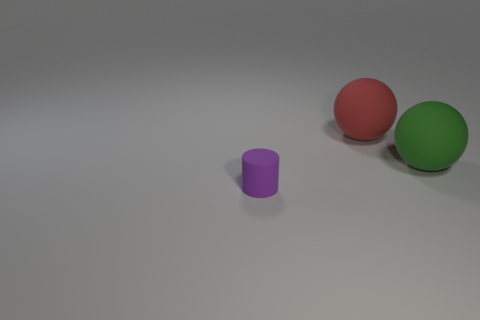Are there any other things that are the same size as the cylinder?
Give a very brief answer. No. What is the size of the purple cylinder that is the same material as the big green thing?
Your answer should be very brief. Small. The ball to the left of the big thing that is to the right of the big red matte object is what color?
Your answer should be compact. Red. How many other things are the same material as the tiny object?
Provide a short and direct response. 2. How many metal things are either small purple objects or spheres?
Offer a very short reply. 0. Are there any green things made of the same material as the big red object?
Give a very brief answer. Yes. The object behind the matte thing that is to the right of the big ball that is behind the big green matte object is what shape?
Your answer should be compact. Sphere. Do the cylinder and the ball to the left of the large green rubber object have the same size?
Ensure brevity in your answer.  No. What is the shape of the rubber thing that is both in front of the red sphere and behind the purple cylinder?
Provide a short and direct response. Sphere. How many tiny objects are purple cylinders or brown balls?
Give a very brief answer. 1. 